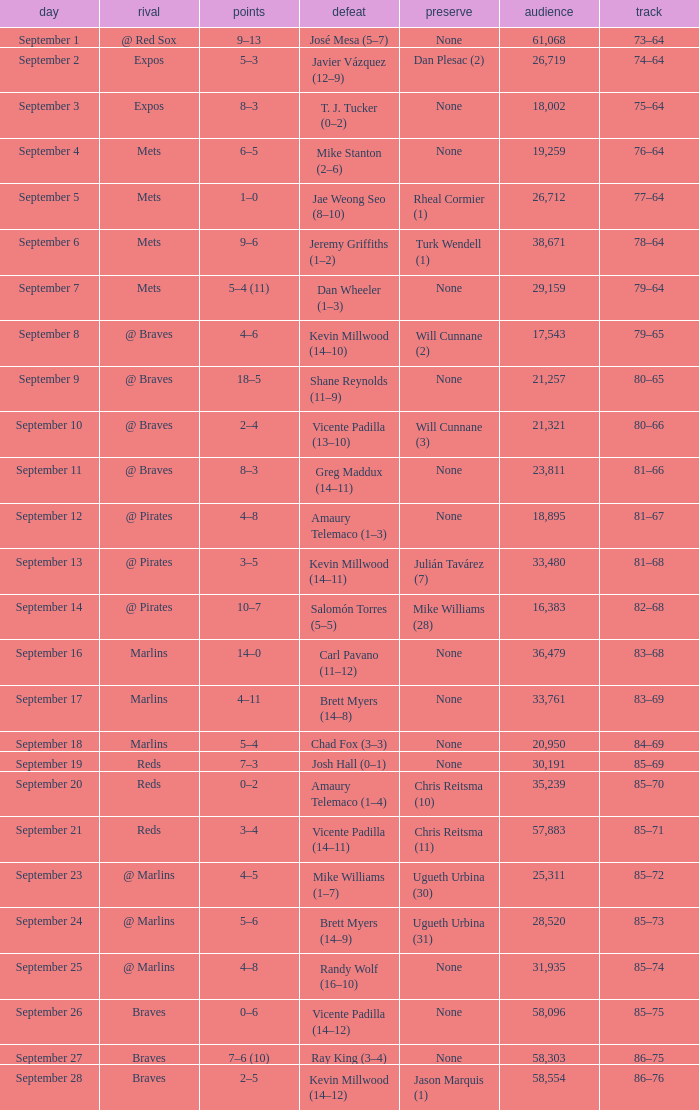What was the attendance at game with a loss of Josh Hall (0–1)? 30191.0. 